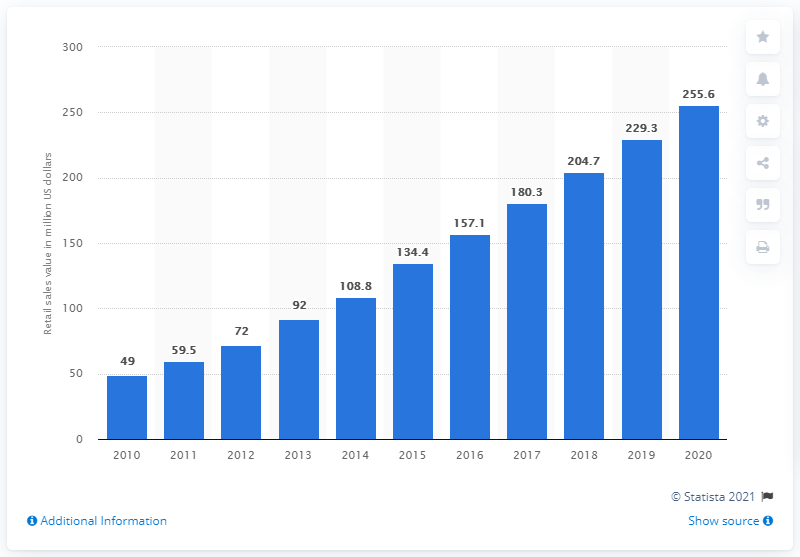Give some essential details in this illustration. The sales value of meat substitutes in Germany in 2020 was 255.6 million euros. The sales value of meat substitutes in 2010 was approximately $49 million. In 2010, the sales value of meat substitutes was forecasted in Germany. According to forecasts, the sales value of meat substitutes is expected to increase significantly in the year 2020. 